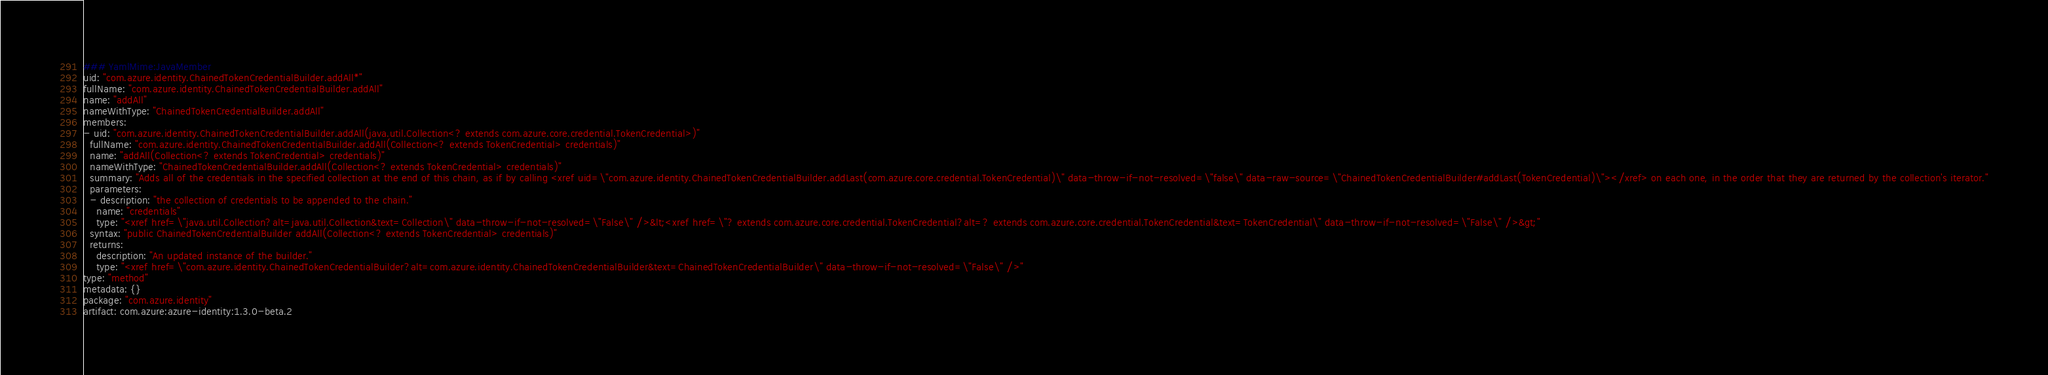<code> <loc_0><loc_0><loc_500><loc_500><_YAML_>### YamlMime:JavaMember
uid: "com.azure.identity.ChainedTokenCredentialBuilder.addAll*"
fullName: "com.azure.identity.ChainedTokenCredentialBuilder.addAll"
name: "addAll"
nameWithType: "ChainedTokenCredentialBuilder.addAll"
members:
- uid: "com.azure.identity.ChainedTokenCredentialBuilder.addAll(java.util.Collection<? extends com.azure.core.credential.TokenCredential>)"
  fullName: "com.azure.identity.ChainedTokenCredentialBuilder.addAll(Collection<? extends TokenCredential> credentials)"
  name: "addAll(Collection<? extends TokenCredential> credentials)"
  nameWithType: "ChainedTokenCredentialBuilder.addAll(Collection<? extends TokenCredential> credentials)"
  summary: "Adds all of the credentials in the specified collection at the end of this chain, as if by calling <xref uid=\"com.azure.identity.ChainedTokenCredentialBuilder.addLast(com.azure.core.credential.TokenCredential)\" data-throw-if-not-resolved=\"false\" data-raw-source=\"ChainedTokenCredentialBuilder#addLast(TokenCredential)\"></xref> on each one, in the order that they are returned by the collection's iterator."
  parameters:
  - description: "the collection of credentials to be appended to the chain."
    name: "credentials"
    type: "<xref href=\"java.util.Collection?alt=java.util.Collection&text=Collection\" data-throw-if-not-resolved=\"False\" />&lt;<xref href=\"? extends com.azure.core.credential.TokenCredential?alt=? extends com.azure.core.credential.TokenCredential&text=TokenCredential\" data-throw-if-not-resolved=\"False\" />&gt;"
  syntax: "public ChainedTokenCredentialBuilder addAll(Collection<? extends TokenCredential> credentials)"
  returns:
    description: "An updated instance of the builder."
    type: "<xref href=\"com.azure.identity.ChainedTokenCredentialBuilder?alt=com.azure.identity.ChainedTokenCredentialBuilder&text=ChainedTokenCredentialBuilder\" data-throw-if-not-resolved=\"False\" />"
type: "method"
metadata: {}
package: "com.azure.identity"
artifact: com.azure:azure-identity:1.3.0-beta.2
</code> 